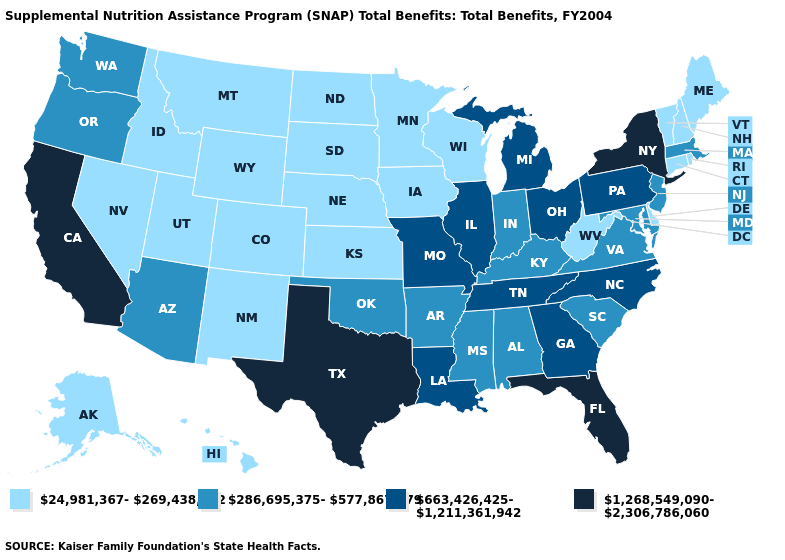What is the value of Ohio?
Be succinct. 663,426,425-1,211,361,942. Name the states that have a value in the range 663,426,425-1,211,361,942?
Write a very short answer. Georgia, Illinois, Louisiana, Michigan, Missouri, North Carolina, Ohio, Pennsylvania, Tennessee. What is the value of North Carolina?
Short answer required. 663,426,425-1,211,361,942. What is the value of Colorado?
Give a very brief answer. 24,981,367-269,438,872. What is the lowest value in states that border New Jersey?
Concise answer only. 24,981,367-269,438,872. Name the states that have a value in the range 286,695,375-577,867,879?
Short answer required. Alabama, Arizona, Arkansas, Indiana, Kentucky, Maryland, Massachusetts, Mississippi, New Jersey, Oklahoma, Oregon, South Carolina, Virginia, Washington. Does Iowa have a lower value than Arkansas?
Answer briefly. Yes. Does Minnesota have the lowest value in the USA?
Be succinct. Yes. Does the first symbol in the legend represent the smallest category?
Answer briefly. Yes. Name the states that have a value in the range 286,695,375-577,867,879?
Concise answer only. Alabama, Arizona, Arkansas, Indiana, Kentucky, Maryland, Massachusetts, Mississippi, New Jersey, Oklahoma, Oregon, South Carolina, Virginia, Washington. Name the states that have a value in the range 24,981,367-269,438,872?
Short answer required. Alaska, Colorado, Connecticut, Delaware, Hawaii, Idaho, Iowa, Kansas, Maine, Minnesota, Montana, Nebraska, Nevada, New Hampshire, New Mexico, North Dakota, Rhode Island, South Dakota, Utah, Vermont, West Virginia, Wisconsin, Wyoming. What is the value of Kentucky?
Quick response, please. 286,695,375-577,867,879. Does Nevada have a lower value than West Virginia?
Short answer required. No. Name the states that have a value in the range 24,981,367-269,438,872?
Concise answer only. Alaska, Colorado, Connecticut, Delaware, Hawaii, Idaho, Iowa, Kansas, Maine, Minnesota, Montana, Nebraska, Nevada, New Hampshire, New Mexico, North Dakota, Rhode Island, South Dakota, Utah, Vermont, West Virginia, Wisconsin, Wyoming. Among the states that border Connecticut , which have the lowest value?
Short answer required. Rhode Island. 